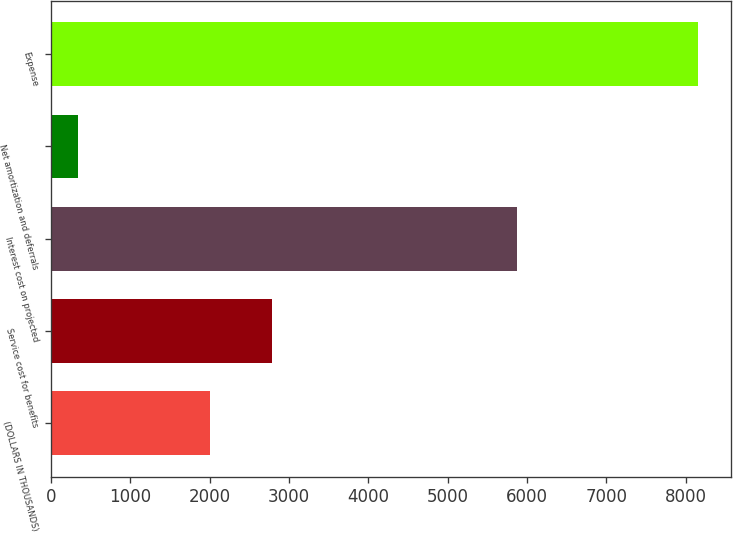Convert chart to OTSL. <chart><loc_0><loc_0><loc_500><loc_500><bar_chart><fcel>(DOLLARS IN THOUSANDS)<fcel>Service cost for benefits<fcel>Interest cost on projected<fcel>Net amortization and deferrals<fcel>Expense<nl><fcel>2007<fcel>2788.7<fcel>5869<fcel>340<fcel>8157<nl></chart> 